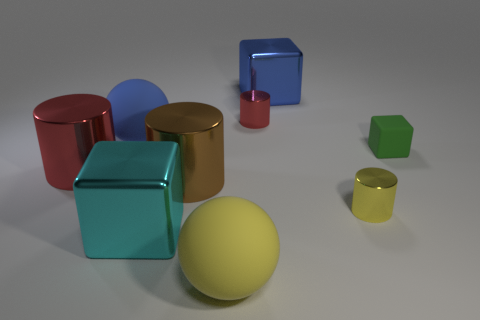How many big spheres are there?
Make the answer very short. 2. Are there any other rubber cubes that have the same size as the cyan block?
Your response must be concise. No. Do the brown cylinder and the big blue object that is to the left of the large yellow matte thing have the same material?
Provide a succinct answer. No. What is the large brown cylinder that is in front of the blue metal cube made of?
Offer a terse response. Metal. What size is the brown metallic cylinder?
Make the answer very short. Large. There is a cyan block that is in front of the tiny green cube; is it the same size as the matte ball behind the big yellow sphere?
Offer a terse response. Yes. There is another red metal object that is the same shape as the tiny red object; what is its size?
Give a very brief answer. Large. Does the yellow matte object have the same size as the red metal cylinder that is in front of the rubber cube?
Offer a very short reply. Yes. Are there any big blue metal blocks to the left of the red metal object that is right of the cyan block?
Ensure brevity in your answer.  No. There is a blue thing that is in front of the large blue metallic object; what shape is it?
Provide a short and direct response. Sphere. 